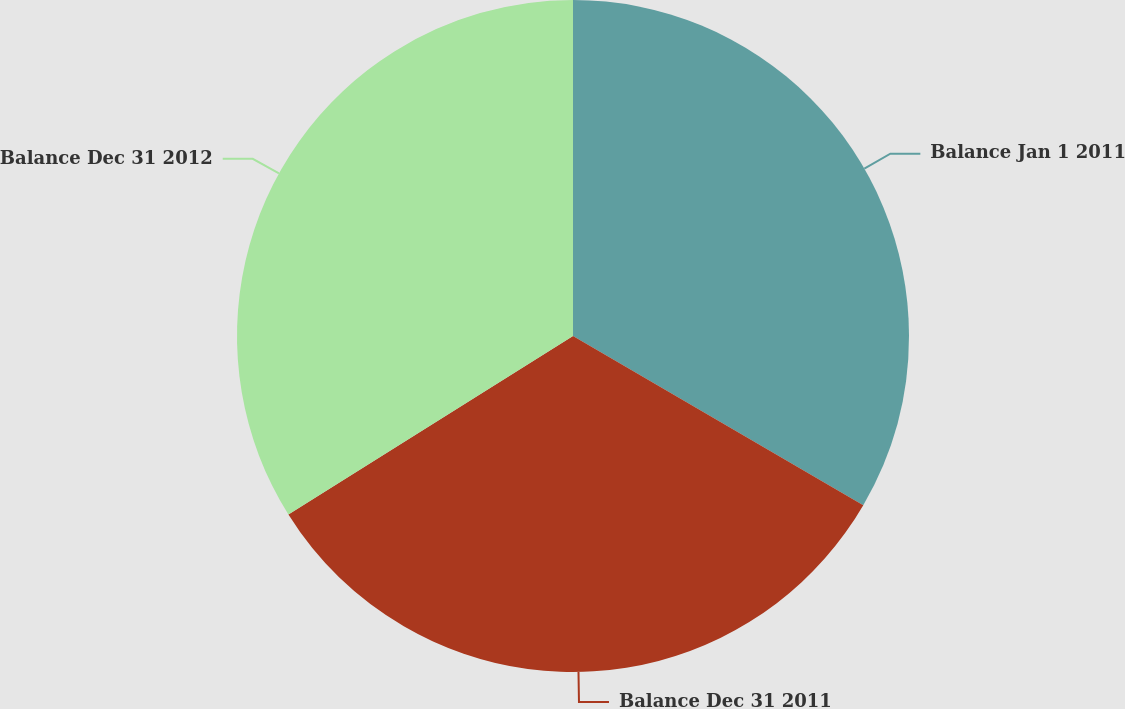Convert chart to OTSL. <chart><loc_0><loc_0><loc_500><loc_500><pie_chart><fcel>Balance Jan 1 2011<fcel>Balance Dec 31 2011<fcel>Balance Dec 31 2012<nl><fcel>33.4%<fcel>32.68%<fcel>33.92%<nl></chart> 